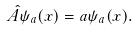Convert formula to latex. <formula><loc_0><loc_0><loc_500><loc_500>\hat { A } \psi _ { a } ( x ) = a \psi _ { a } ( x ) .</formula> 